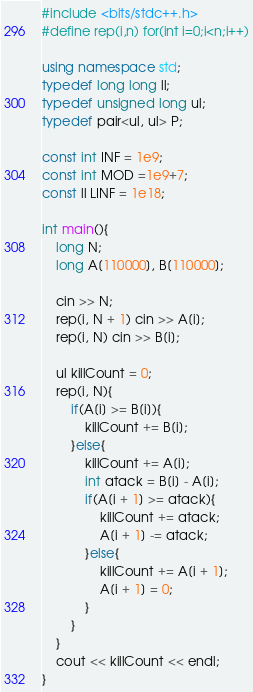<code> <loc_0><loc_0><loc_500><loc_500><_C++_>#include <bits/stdc++.h>
#define rep(i,n) for(int i=0;i<n;i++)

using namespace std;
typedef long long ll;
typedef unsigned long ul;
typedef pair<ul, ul> P;

const int INF = 1e9;
const int MOD =1e9+7;
const ll LINF = 1e18;

int main(){
    long N;
    long A[110000], B[110000];

    cin >> N;
    rep(i, N + 1) cin >> A[i];
    rep(i, N) cin >> B[i];

    ul killCount = 0;
    rep(i, N){
        if(A[i] >= B[i]){
            killCount += B[i];
        }else{
            killCount += A[i];
            int atack = B[i] - A[i];
            if(A[i + 1] >= atack){
                killCount += atack;
                A[i + 1] -= atack;
            }else{
                killCount += A[i + 1];
                A[i + 1] = 0;
            }
        }
    }
    cout << killCount << endl;
}</code> 